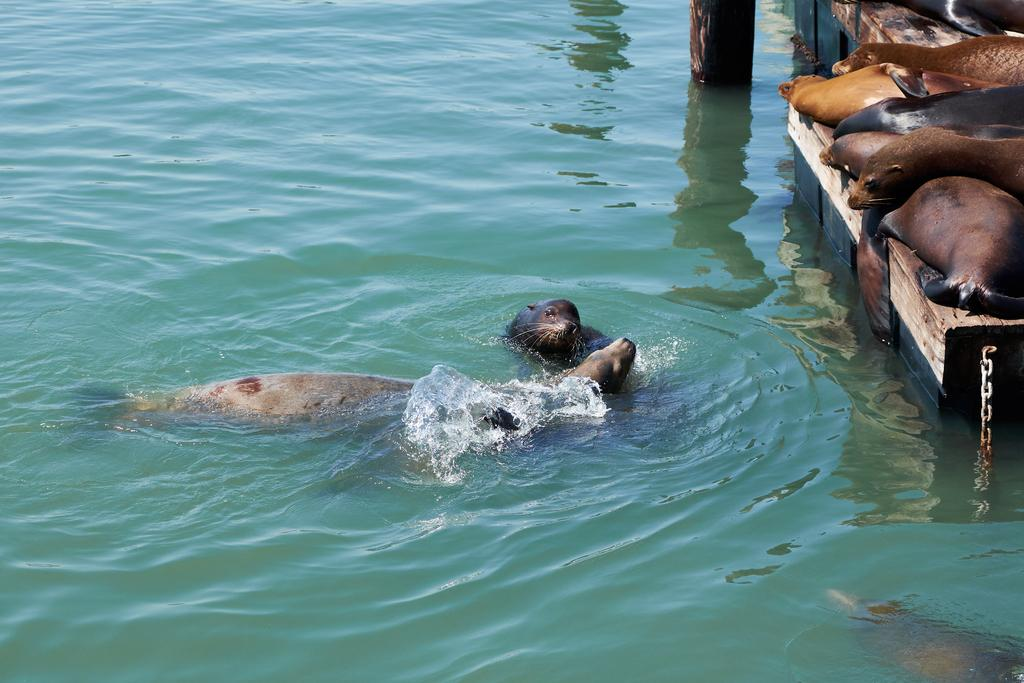What animals are present on the wooden surface in the image? There are seals on a wooden surface on the right side of the image. Where are more seals located in the image? There are more seals in the water in the middle of the image. Can you describe the environment in which the seals are situated? The seals are on a wooden surface and in the water, suggesting a coastal or marine setting. What is the outcome of the battle between the seals and the sharks in the image? There is no battle between seals and sharks depicted in the image. 